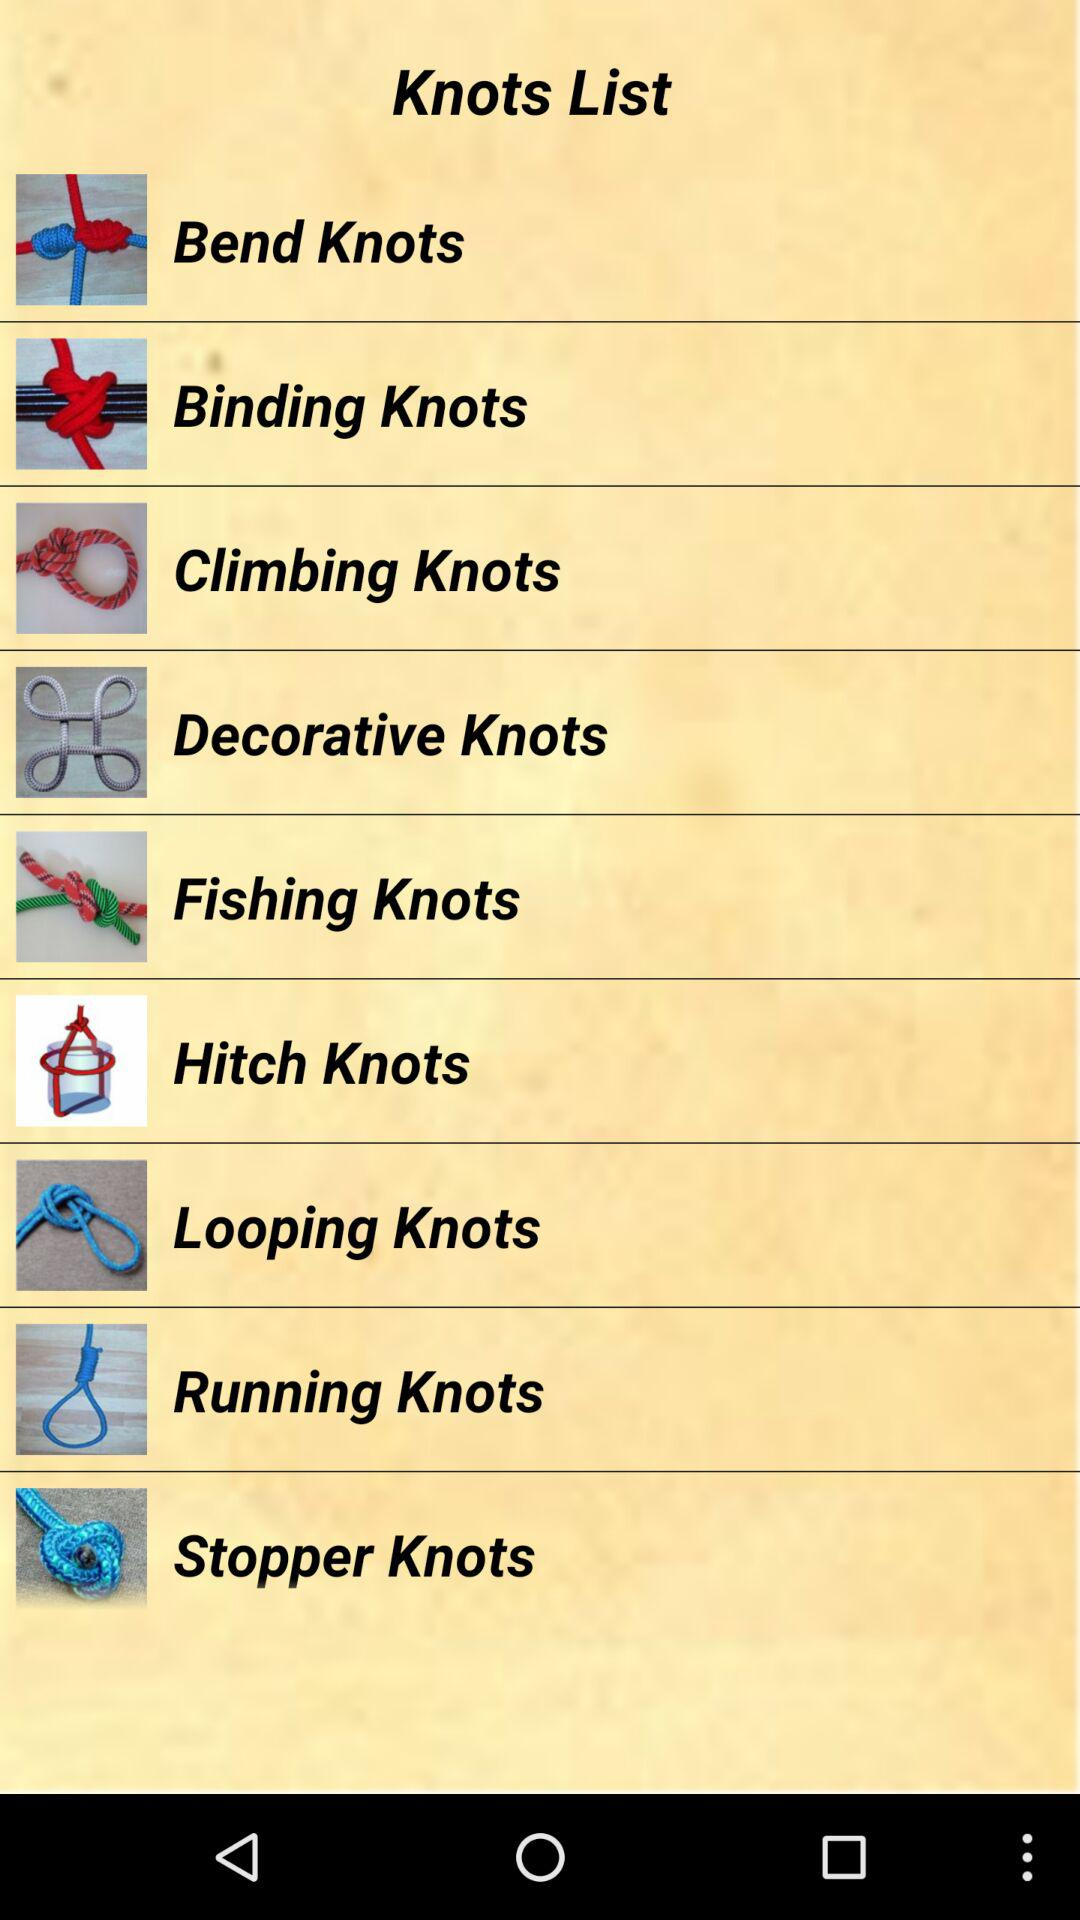How many knots are there in total?
Answer the question using a single word or phrase. 9 